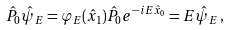<formula> <loc_0><loc_0><loc_500><loc_500>\hat { P } _ { 0 } \hat { \psi } _ { E } = \varphi _ { E } ( \hat { x } _ { 1 } ) \hat { P } _ { 0 } e ^ { - i E \hat { x } _ { 0 } } = E \hat { \psi } _ { E } \, ,</formula> 